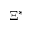<formula> <loc_0><loc_0><loc_500><loc_500>\Xi ^ { * }</formula> 